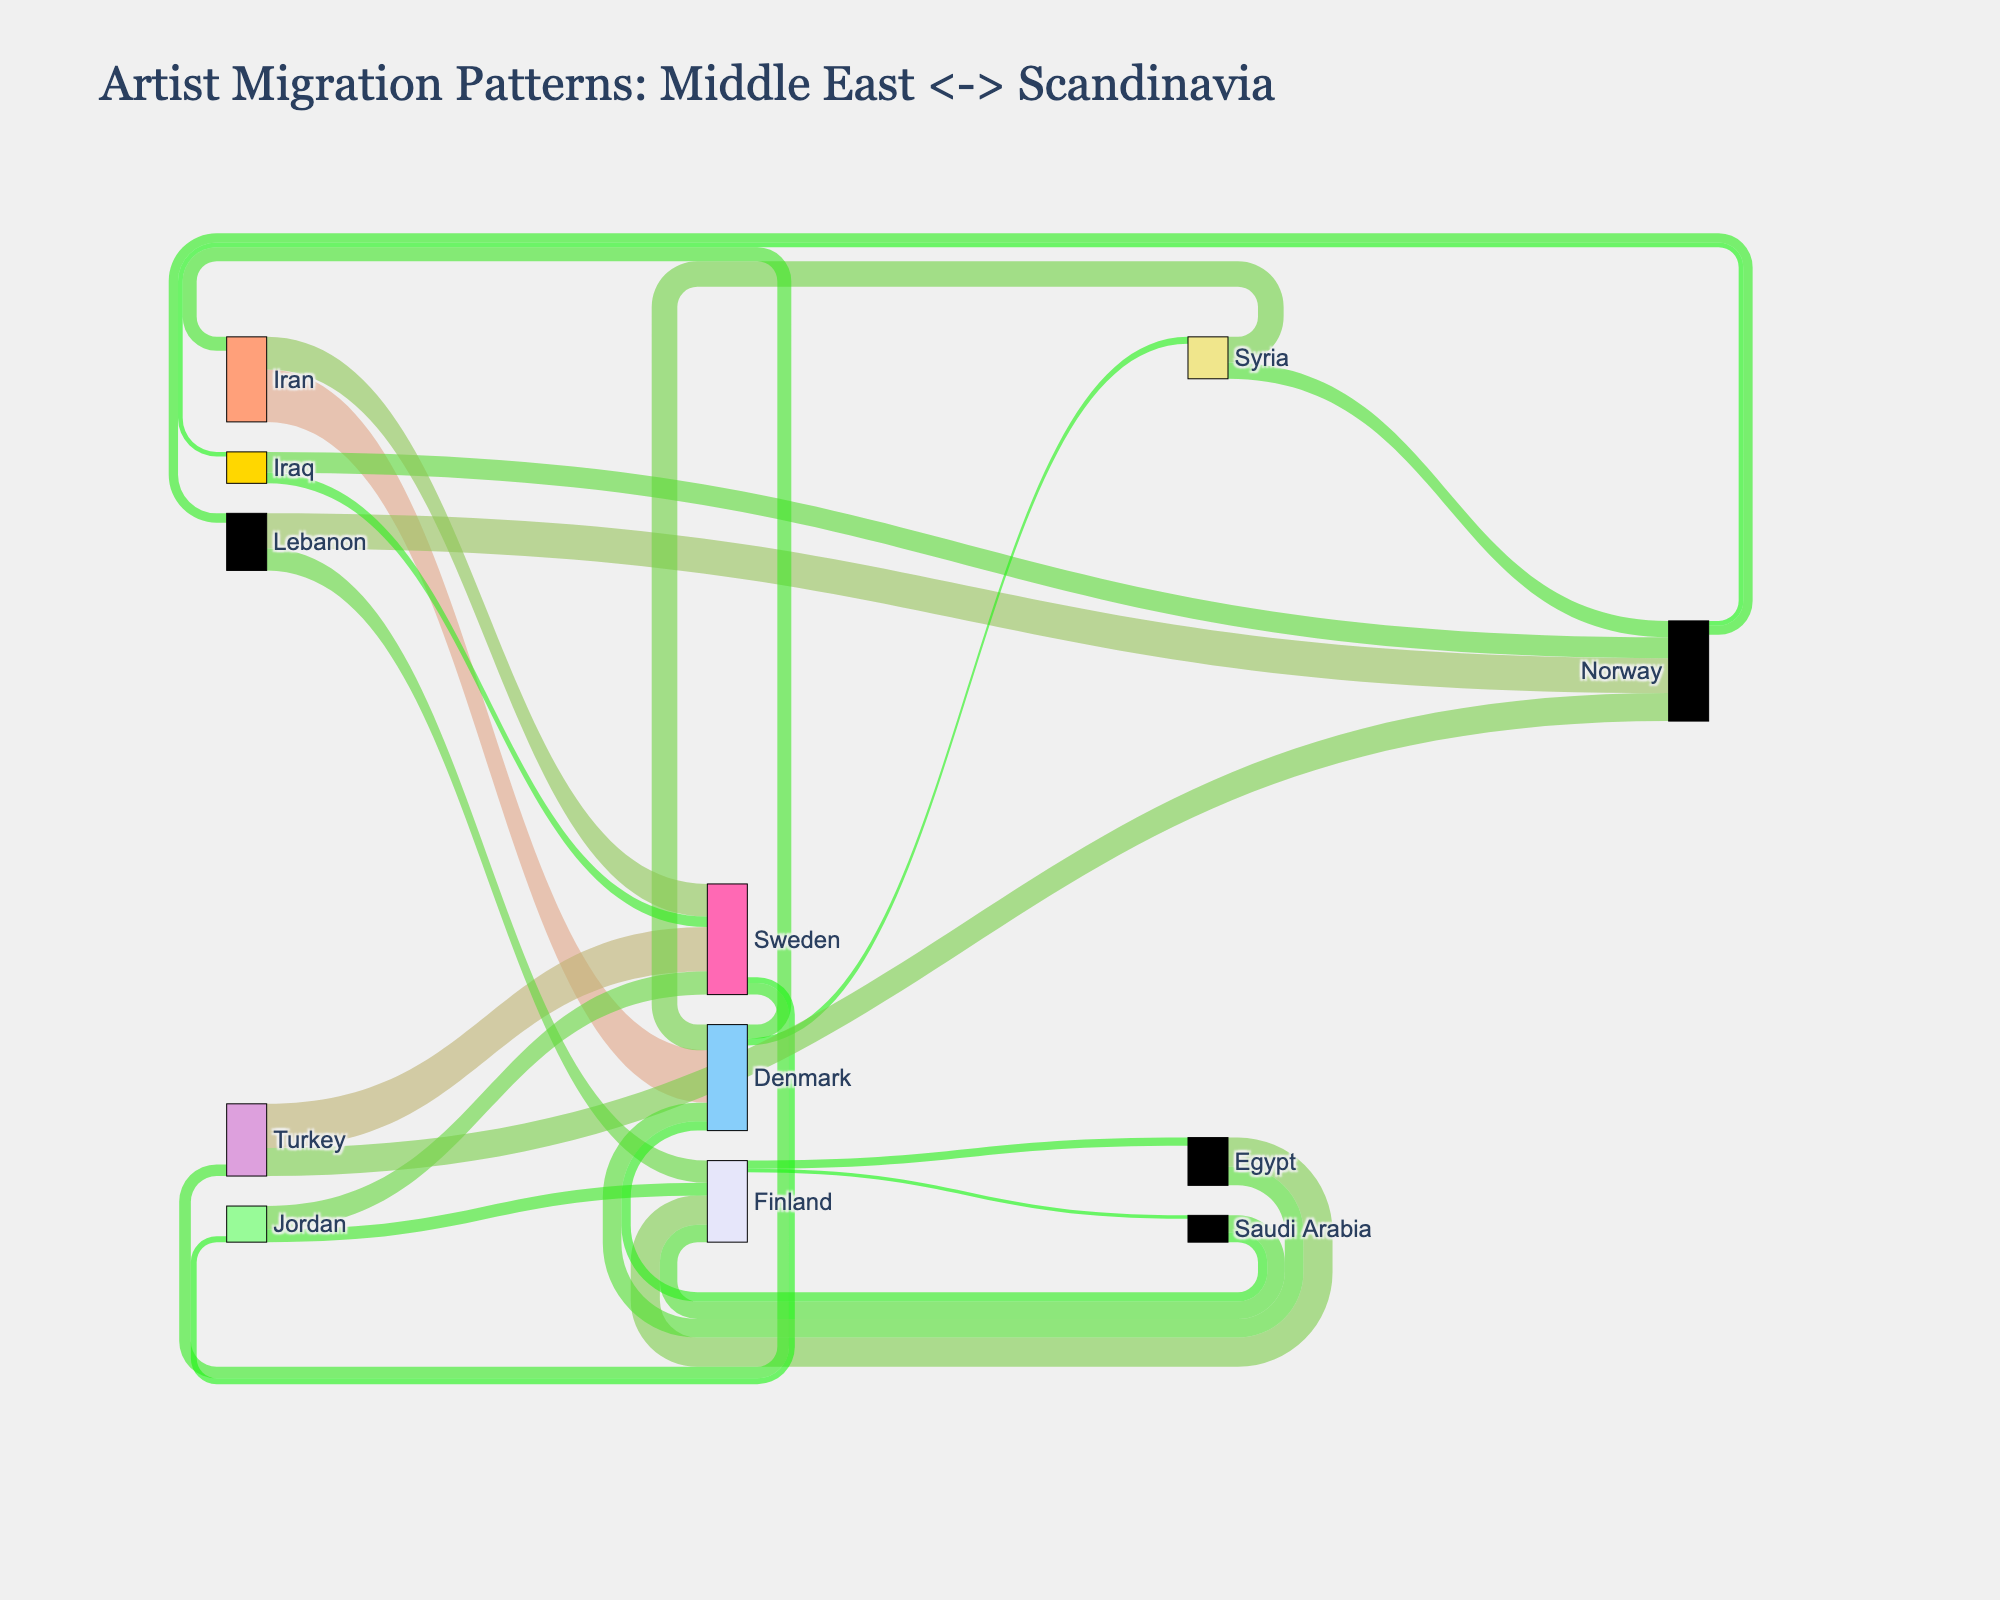What is the overall title of the figure? The title is usually placed at the top of the figure for easy identification. Here it is visually prominent in larger font size.
Answer: "Artist Migration Patterns: Middle East <-> Scandinavia" Which Middle Eastern country has the highest artist migration to Denmark? By tracing the flow lines leading into Denmark from the Middle Eastern countries, one can observe that Iran has the largest flow to Denmark.
Answer: Iran How many countries in total are involved in artist migration between Middle Eastern and Scandinavian countries? Count all distinct countries mentioned as either sources or targets in the Sankey diagram's nodes.
Answer: 16 Which Scandinavian country has the least incoming artist migration from the Middle Eastern countries? Observe the Sankey diagram and note the Scandinavian country with the smallest aggregate flow of incoming migration from the Middle Eastern countries.
Answer: Finland What is the total number of artists migrating from Iran? Summing up the values flowing out of Iran, 45 (to Denmark) + 28 (to Sweden).
Answer: 73 Compare the artist migration from Turkey to Scandinavian countries. Which country receives more artists, and by how much? Compare the sizes of the flows from Turkey to Sweden (38) and Norway (24), then find the difference.
Answer: Sweden, by 14 artists What is the difference between the number of artists migrating from Syria to Norway and Denmark? Compare the flow sizes from Syria to Norway (14) and Denmark (22), and calculate the difference.
Answer: 8 Identify which Scandinavian country sends more artists back to the Middle East and specify the number of artists. Count the outgoing flows from each Scandinavian country to the Middle East, noting Denmark sends 12 to Iran, 6 to Syria, and 8 to Saudi Arabia.
Answer: Denmark, 26 artists What is the average number of artists migrating from the Middle Eastern countries to Scandinavian countries? Sum the migration values from all Middle Eastern countries to Scandinavian countries and divide by the number of such flows: (45+38+30+25+22+20+18+15+28+24+19+16+14+11+9+8) / 16.
Answer: 22 Which Middle Eastern country has the smallest artist migration to Finland? Observe the flows to Finland from Middle Eastern countries and identify the smallest flow.
Answer: Saudi Arabia 